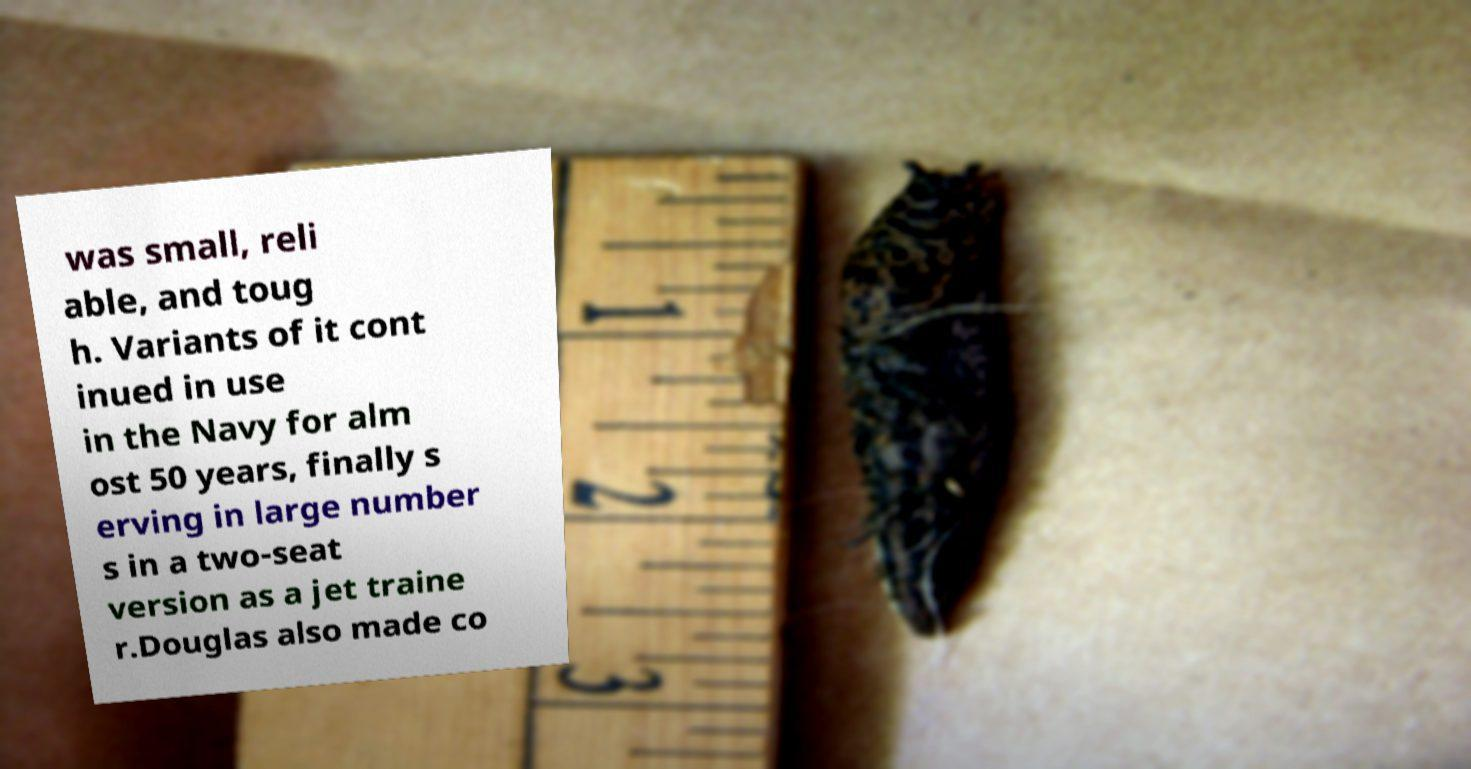Please read and relay the text visible in this image. What does it say? was small, reli able, and toug h. Variants of it cont inued in use in the Navy for alm ost 50 years, finally s erving in large number s in a two-seat version as a jet traine r.Douglas also made co 